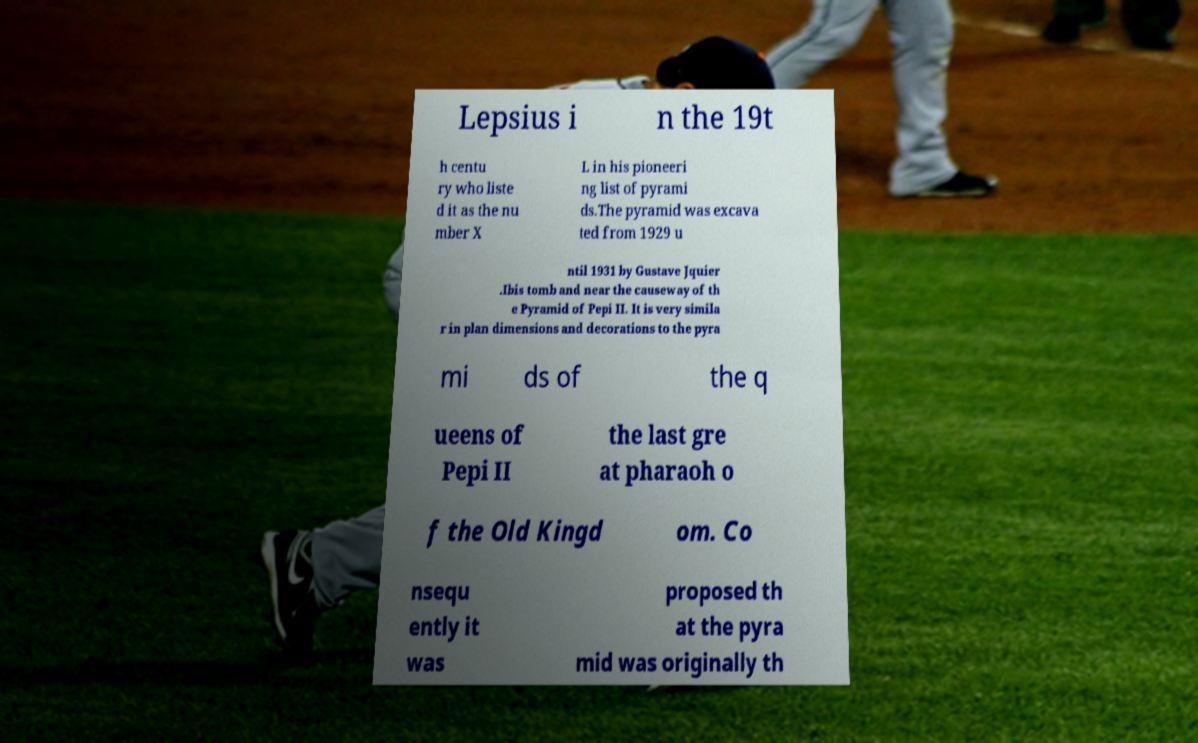Can you accurately transcribe the text from the provided image for me? Lepsius i n the 19t h centu ry who liste d it as the nu mber X L in his pioneeri ng list of pyrami ds.The pyramid was excava ted from 1929 u ntil 1931 by Gustave Jquier .Ibis tomb and near the causeway of th e Pyramid of Pepi II. It is very simila r in plan dimensions and decorations to the pyra mi ds of the q ueens of Pepi II the last gre at pharaoh o f the Old Kingd om. Co nsequ ently it was proposed th at the pyra mid was originally th 